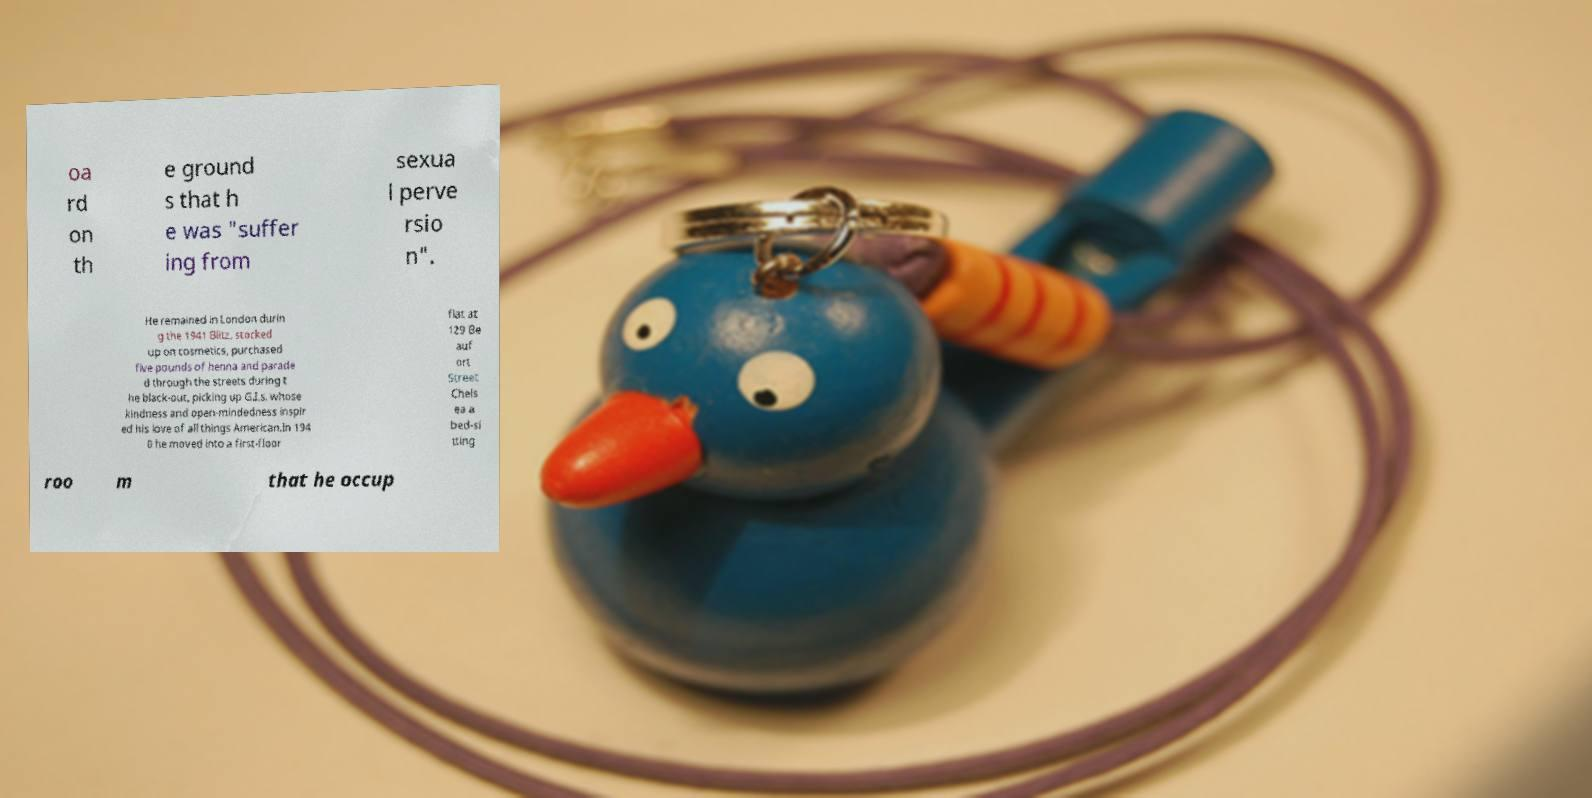Please identify and transcribe the text found in this image. oa rd on th e ground s that h e was "suffer ing from sexua l perve rsio n". He remained in London durin g the 1941 Blitz, stocked up on cosmetics, purchased five pounds of henna and parade d through the streets during t he black-out, picking up G.I.s, whose kindness and open-mindedness inspir ed his love of all things American.In 194 0 he moved into a first-floor flat at 129 Be auf ort Street Chels ea a bed-si tting roo m that he occup 